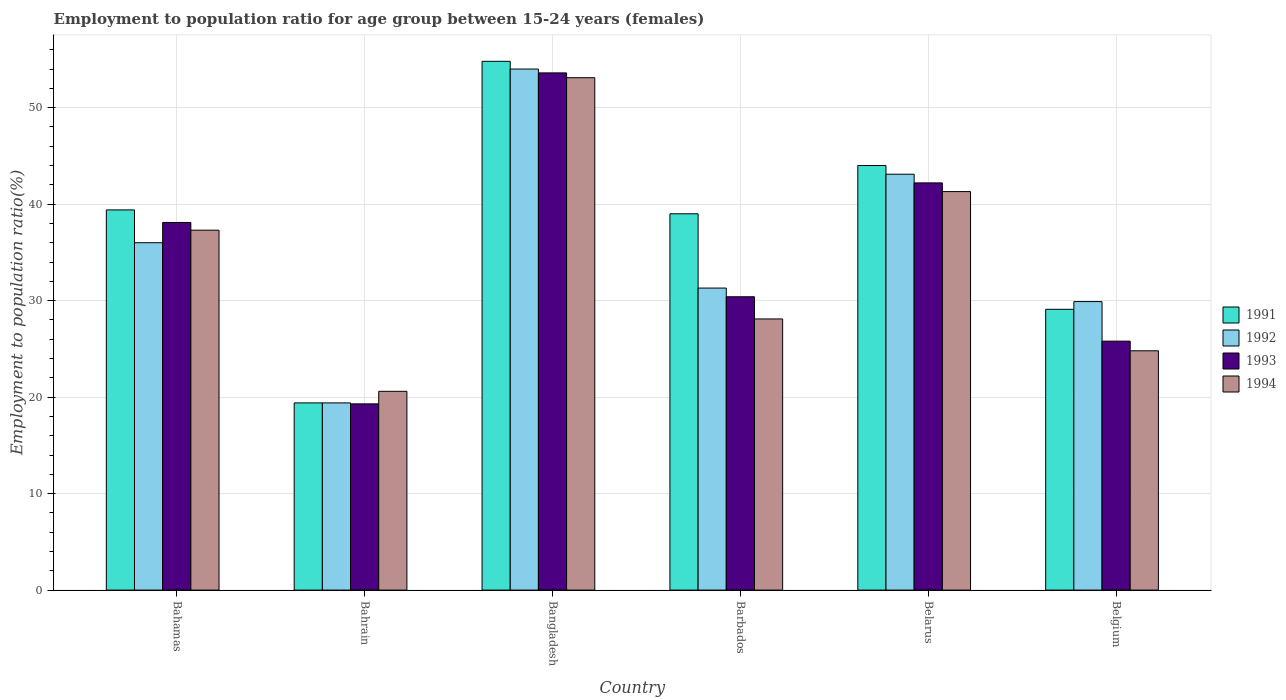Are the number of bars per tick equal to the number of legend labels?
Make the answer very short. Yes. How many bars are there on the 6th tick from the left?
Your answer should be compact. 4. How many bars are there on the 6th tick from the right?
Make the answer very short. 4. What is the label of the 2nd group of bars from the left?
Provide a succinct answer. Bahrain. In how many cases, is the number of bars for a given country not equal to the number of legend labels?
Offer a terse response. 0. What is the employment to population ratio in 1993 in Bangladesh?
Ensure brevity in your answer.  53.6. Across all countries, what is the maximum employment to population ratio in 1993?
Ensure brevity in your answer.  53.6. Across all countries, what is the minimum employment to population ratio in 1991?
Ensure brevity in your answer.  19.4. In which country was the employment to population ratio in 1992 minimum?
Make the answer very short. Bahrain. What is the total employment to population ratio in 1994 in the graph?
Your response must be concise. 205.2. What is the difference between the employment to population ratio in 1991 in Bahamas and that in Bangladesh?
Your answer should be very brief. -15.4. What is the difference between the employment to population ratio in 1994 in Belgium and the employment to population ratio in 1991 in Barbados?
Your answer should be compact. -14.2. What is the average employment to population ratio in 1991 per country?
Provide a short and direct response. 37.62. What is the difference between the employment to population ratio of/in 1991 and employment to population ratio of/in 1992 in Bahrain?
Your answer should be very brief. 0. In how many countries, is the employment to population ratio in 1991 greater than 8 %?
Provide a succinct answer. 6. What is the ratio of the employment to population ratio in 1991 in Bahamas to that in Bangladesh?
Offer a terse response. 0.72. Is the difference between the employment to population ratio in 1991 in Bahrain and Barbados greater than the difference between the employment to population ratio in 1992 in Bahrain and Barbados?
Your answer should be compact. No. What is the difference between the highest and the second highest employment to population ratio in 1991?
Offer a terse response. -10.8. What is the difference between the highest and the lowest employment to population ratio in 1994?
Make the answer very short. 32.5. In how many countries, is the employment to population ratio in 1992 greater than the average employment to population ratio in 1992 taken over all countries?
Offer a very short reply. 3. Is the sum of the employment to population ratio in 1993 in Barbados and Belgium greater than the maximum employment to population ratio in 1994 across all countries?
Ensure brevity in your answer.  Yes. Is it the case that in every country, the sum of the employment to population ratio in 1993 and employment to population ratio in 1992 is greater than the sum of employment to population ratio in 1991 and employment to population ratio in 1994?
Your response must be concise. No. What does the 1st bar from the left in Belgium represents?
Keep it short and to the point. 1991. What does the 3rd bar from the right in Bahamas represents?
Offer a very short reply. 1992. How many bars are there?
Ensure brevity in your answer.  24. Does the graph contain any zero values?
Your answer should be compact. No. How many legend labels are there?
Your response must be concise. 4. How are the legend labels stacked?
Offer a terse response. Vertical. What is the title of the graph?
Ensure brevity in your answer.  Employment to population ratio for age group between 15-24 years (females). What is the Employment to population ratio(%) of 1991 in Bahamas?
Offer a very short reply. 39.4. What is the Employment to population ratio(%) in 1992 in Bahamas?
Ensure brevity in your answer.  36. What is the Employment to population ratio(%) in 1993 in Bahamas?
Provide a short and direct response. 38.1. What is the Employment to population ratio(%) of 1994 in Bahamas?
Keep it short and to the point. 37.3. What is the Employment to population ratio(%) in 1991 in Bahrain?
Ensure brevity in your answer.  19.4. What is the Employment to population ratio(%) of 1992 in Bahrain?
Provide a succinct answer. 19.4. What is the Employment to population ratio(%) in 1993 in Bahrain?
Your answer should be very brief. 19.3. What is the Employment to population ratio(%) of 1994 in Bahrain?
Your response must be concise. 20.6. What is the Employment to population ratio(%) of 1991 in Bangladesh?
Provide a succinct answer. 54.8. What is the Employment to population ratio(%) in 1993 in Bangladesh?
Your answer should be compact. 53.6. What is the Employment to population ratio(%) of 1994 in Bangladesh?
Your answer should be compact. 53.1. What is the Employment to population ratio(%) of 1992 in Barbados?
Offer a very short reply. 31.3. What is the Employment to population ratio(%) of 1993 in Barbados?
Give a very brief answer. 30.4. What is the Employment to population ratio(%) of 1994 in Barbados?
Provide a succinct answer. 28.1. What is the Employment to population ratio(%) of 1991 in Belarus?
Your response must be concise. 44. What is the Employment to population ratio(%) of 1992 in Belarus?
Your answer should be compact. 43.1. What is the Employment to population ratio(%) in 1993 in Belarus?
Make the answer very short. 42.2. What is the Employment to population ratio(%) of 1994 in Belarus?
Provide a succinct answer. 41.3. What is the Employment to population ratio(%) in 1991 in Belgium?
Provide a short and direct response. 29.1. What is the Employment to population ratio(%) in 1992 in Belgium?
Make the answer very short. 29.9. What is the Employment to population ratio(%) in 1993 in Belgium?
Offer a terse response. 25.8. What is the Employment to population ratio(%) of 1994 in Belgium?
Provide a short and direct response. 24.8. Across all countries, what is the maximum Employment to population ratio(%) in 1991?
Offer a terse response. 54.8. Across all countries, what is the maximum Employment to population ratio(%) of 1993?
Ensure brevity in your answer.  53.6. Across all countries, what is the maximum Employment to population ratio(%) of 1994?
Give a very brief answer. 53.1. Across all countries, what is the minimum Employment to population ratio(%) in 1991?
Provide a succinct answer. 19.4. Across all countries, what is the minimum Employment to population ratio(%) in 1992?
Ensure brevity in your answer.  19.4. Across all countries, what is the minimum Employment to population ratio(%) of 1993?
Your answer should be compact. 19.3. Across all countries, what is the minimum Employment to population ratio(%) of 1994?
Your response must be concise. 20.6. What is the total Employment to population ratio(%) in 1991 in the graph?
Provide a short and direct response. 225.7. What is the total Employment to population ratio(%) in 1992 in the graph?
Make the answer very short. 213.7. What is the total Employment to population ratio(%) in 1993 in the graph?
Provide a short and direct response. 209.4. What is the total Employment to population ratio(%) of 1994 in the graph?
Your answer should be very brief. 205.2. What is the difference between the Employment to population ratio(%) of 1991 in Bahamas and that in Bahrain?
Make the answer very short. 20. What is the difference between the Employment to population ratio(%) in 1992 in Bahamas and that in Bahrain?
Provide a short and direct response. 16.6. What is the difference between the Employment to population ratio(%) in 1994 in Bahamas and that in Bahrain?
Offer a very short reply. 16.7. What is the difference between the Employment to population ratio(%) of 1991 in Bahamas and that in Bangladesh?
Your response must be concise. -15.4. What is the difference between the Employment to population ratio(%) of 1993 in Bahamas and that in Bangladesh?
Ensure brevity in your answer.  -15.5. What is the difference between the Employment to population ratio(%) of 1994 in Bahamas and that in Bangladesh?
Your response must be concise. -15.8. What is the difference between the Employment to population ratio(%) in 1992 in Bahamas and that in Barbados?
Your answer should be compact. 4.7. What is the difference between the Employment to population ratio(%) in 1993 in Bahamas and that in Barbados?
Your answer should be compact. 7.7. What is the difference between the Employment to population ratio(%) in 1994 in Bahamas and that in Barbados?
Make the answer very short. 9.2. What is the difference between the Employment to population ratio(%) of 1991 in Bahamas and that in Belarus?
Your response must be concise. -4.6. What is the difference between the Employment to population ratio(%) of 1992 in Bahamas and that in Belarus?
Offer a terse response. -7.1. What is the difference between the Employment to population ratio(%) of 1993 in Bahamas and that in Belarus?
Give a very brief answer. -4.1. What is the difference between the Employment to population ratio(%) of 1994 in Bahamas and that in Belarus?
Keep it short and to the point. -4. What is the difference between the Employment to population ratio(%) of 1991 in Bahamas and that in Belgium?
Keep it short and to the point. 10.3. What is the difference between the Employment to population ratio(%) in 1992 in Bahamas and that in Belgium?
Ensure brevity in your answer.  6.1. What is the difference between the Employment to population ratio(%) in 1993 in Bahamas and that in Belgium?
Give a very brief answer. 12.3. What is the difference between the Employment to population ratio(%) in 1991 in Bahrain and that in Bangladesh?
Keep it short and to the point. -35.4. What is the difference between the Employment to population ratio(%) in 1992 in Bahrain and that in Bangladesh?
Provide a succinct answer. -34.6. What is the difference between the Employment to population ratio(%) of 1993 in Bahrain and that in Bangladesh?
Provide a succinct answer. -34.3. What is the difference between the Employment to population ratio(%) of 1994 in Bahrain and that in Bangladesh?
Ensure brevity in your answer.  -32.5. What is the difference between the Employment to population ratio(%) in 1991 in Bahrain and that in Barbados?
Your answer should be compact. -19.6. What is the difference between the Employment to population ratio(%) of 1992 in Bahrain and that in Barbados?
Provide a short and direct response. -11.9. What is the difference between the Employment to population ratio(%) in 1993 in Bahrain and that in Barbados?
Give a very brief answer. -11.1. What is the difference between the Employment to population ratio(%) in 1994 in Bahrain and that in Barbados?
Your answer should be very brief. -7.5. What is the difference between the Employment to population ratio(%) of 1991 in Bahrain and that in Belarus?
Your answer should be compact. -24.6. What is the difference between the Employment to population ratio(%) of 1992 in Bahrain and that in Belarus?
Provide a succinct answer. -23.7. What is the difference between the Employment to population ratio(%) in 1993 in Bahrain and that in Belarus?
Give a very brief answer. -22.9. What is the difference between the Employment to population ratio(%) in 1994 in Bahrain and that in Belarus?
Offer a very short reply. -20.7. What is the difference between the Employment to population ratio(%) of 1991 in Bahrain and that in Belgium?
Make the answer very short. -9.7. What is the difference between the Employment to population ratio(%) of 1992 in Bahrain and that in Belgium?
Make the answer very short. -10.5. What is the difference between the Employment to population ratio(%) of 1994 in Bahrain and that in Belgium?
Your answer should be very brief. -4.2. What is the difference between the Employment to population ratio(%) of 1992 in Bangladesh and that in Barbados?
Offer a terse response. 22.7. What is the difference between the Employment to population ratio(%) in 1993 in Bangladesh and that in Barbados?
Make the answer very short. 23.2. What is the difference between the Employment to population ratio(%) in 1991 in Bangladesh and that in Belarus?
Offer a very short reply. 10.8. What is the difference between the Employment to population ratio(%) in 1991 in Bangladesh and that in Belgium?
Keep it short and to the point. 25.7. What is the difference between the Employment to population ratio(%) in 1992 in Bangladesh and that in Belgium?
Keep it short and to the point. 24.1. What is the difference between the Employment to population ratio(%) in 1993 in Bangladesh and that in Belgium?
Give a very brief answer. 27.8. What is the difference between the Employment to population ratio(%) of 1994 in Bangladesh and that in Belgium?
Offer a terse response. 28.3. What is the difference between the Employment to population ratio(%) of 1991 in Barbados and that in Belarus?
Your answer should be compact. -5. What is the difference between the Employment to population ratio(%) in 1993 in Barbados and that in Belgium?
Your answer should be compact. 4.6. What is the difference between the Employment to population ratio(%) of 1991 in Belarus and that in Belgium?
Give a very brief answer. 14.9. What is the difference between the Employment to population ratio(%) in 1992 in Belarus and that in Belgium?
Provide a succinct answer. 13.2. What is the difference between the Employment to population ratio(%) in 1993 in Belarus and that in Belgium?
Give a very brief answer. 16.4. What is the difference between the Employment to population ratio(%) in 1991 in Bahamas and the Employment to population ratio(%) in 1993 in Bahrain?
Provide a succinct answer. 20.1. What is the difference between the Employment to population ratio(%) of 1993 in Bahamas and the Employment to population ratio(%) of 1994 in Bahrain?
Offer a very short reply. 17.5. What is the difference between the Employment to population ratio(%) of 1991 in Bahamas and the Employment to population ratio(%) of 1992 in Bangladesh?
Offer a terse response. -14.6. What is the difference between the Employment to population ratio(%) in 1991 in Bahamas and the Employment to population ratio(%) in 1994 in Bangladesh?
Provide a short and direct response. -13.7. What is the difference between the Employment to population ratio(%) in 1992 in Bahamas and the Employment to population ratio(%) in 1993 in Bangladesh?
Ensure brevity in your answer.  -17.6. What is the difference between the Employment to population ratio(%) in 1992 in Bahamas and the Employment to population ratio(%) in 1994 in Bangladesh?
Offer a very short reply. -17.1. What is the difference between the Employment to population ratio(%) in 1991 in Bahamas and the Employment to population ratio(%) in 1992 in Barbados?
Offer a terse response. 8.1. What is the difference between the Employment to population ratio(%) of 1991 in Bahamas and the Employment to population ratio(%) of 1994 in Barbados?
Your answer should be very brief. 11.3. What is the difference between the Employment to population ratio(%) of 1992 in Bahamas and the Employment to population ratio(%) of 1994 in Barbados?
Keep it short and to the point. 7.9. What is the difference between the Employment to population ratio(%) of 1993 in Bahamas and the Employment to population ratio(%) of 1994 in Barbados?
Provide a succinct answer. 10. What is the difference between the Employment to population ratio(%) in 1991 in Bahamas and the Employment to population ratio(%) in 1992 in Belarus?
Provide a succinct answer. -3.7. What is the difference between the Employment to population ratio(%) in 1991 in Bahamas and the Employment to population ratio(%) in 1993 in Belarus?
Give a very brief answer. -2.8. What is the difference between the Employment to population ratio(%) in 1991 in Bahamas and the Employment to population ratio(%) in 1992 in Belgium?
Offer a terse response. 9.5. What is the difference between the Employment to population ratio(%) of 1991 in Bahamas and the Employment to population ratio(%) of 1993 in Belgium?
Your response must be concise. 13.6. What is the difference between the Employment to population ratio(%) in 1992 in Bahamas and the Employment to population ratio(%) in 1994 in Belgium?
Provide a succinct answer. 11.2. What is the difference between the Employment to population ratio(%) in 1993 in Bahamas and the Employment to population ratio(%) in 1994 in Belgium?
Your answer should be very brief. 13.3. What is the difference between the Employment to population ratio(%) of 1991 in Bahrain and the Employment to population ratio(%) of 1992 in Bangladesh?
Offer a terse response. -34.6. What is the difference between the Employment to population ratio(%) of 1991 in Bahrain and the Employment to population ratio(%) of 1993 in Bangladesh?
Keep it short and to the point. -34.2. What is the difference between the Employment to population ratio(%) in 1991 in Bahrain and the Employment to population ratio(%) in 1994 in Bangladesh?
Your answer should be compact. -33.7. What is the difference between the Employment to population ratio(%) of 1992 in Bahrain and the Employment to population ratio(%) of 1993 in Bangladesh?
Make the answer very short. -34.2. What is the difference between the Employment to population ratio(%) in 1992 in Bahrain and the Employment to population ratio(%) in 1994 in Bangladesh?
Keep it short and to the point. -33.7. What is the difference between the Employment to population ratio(%) of 1993 in Bahrain and the Employment to population ratio(%) of 1994 in Bangladesh?
Your answer should be very brief. -33.8. What is the difference between the Employment to population ratio(%) in 1991 in Bahrain and the Employment to population ratio(%) in 1992 in Barbados?
Your answer should be compact. -11.9. What is the difference between the Employment to population ratio(%) in 1992 in Bahrain and the Employment to population ratio(%) in 1994 in Barbados?
Your answer should be very brief. -8.7. What is the difference between the Employment to population ratio(%) of 1993 in Bahrain and the Employment to population ratio(%) of 1994 in Barbados?
Provide a succinct answer. -8.8. What is the difference between the Employment to population ratio(%) in 1991 in Bahrain and the Employment to population ratio(%) in 1992 in Belarus?
Ensure brevity in your answer.  -23.7. What is the difference between the Employment to population ratio(%) of 1991 in Bahrain and the Employment to population ratio(%) of 1993 in Belarus?
Offer a terse response. -22.8. What is the difference between the Employment to population ratio(%) of 1991 in Bahrain and the Employment to population ratio(%) of 1994 in Belarus?
Your response must be concise. -21.9. What is the difference between the Employment to population ratio(%) in 1992 in Bahrain and the Employment to population ratio(%) in 1993 in Belarus?
Your answer should be very brief. -22.8. What is the difference between the Employment to population ratio(%) of 1992 in Bahrain and the Employment to population ratio(%) of 1994 in Belarus?
Make the answer very short. -21.9. What is the difference between the Employment to population ratio(%) of 1993 in Bahrain and the Employment to population ratio(%) of 1994 in Belarus?
Provide a short and direct response. -22. What is the difference between the Employment to population ratio(%) of 1991 in Bahrain and the Employment to population ratio(%) of 1994 in Belgium?
Provide a succinct answer. -5.4. What is the difference between the Employment to population ratio(%) in 1992 in Bahrain and the Employment to population ratio(%) in 1993 in Belgium?
Your response must be concise. -6.4. What is the difference between the Employment to population ratio(%) in 1992 in Bahrain and the Employment to population ratio(%) in 1994 in Belgium?
Offer a very short reply. -5.4. What is the difference between the Employment to population ratio(%) in 1993 in Bahrain and the Employment to population ratio(%) in 1994 in Belgium?
Provide a succinct answer. -5.5. What is the difference between the Employment to population ratio(%) in 1991 in Bangladesh and the Employment to population ratio(%) in 1992 in Barbados?
Your response must be concise. 23.5. What is the difference between the Employment to population ratio(%) in 1991 in Bangladesh and the Employment to population ratio(%) in 1993 in Barbados?
Make the answer very short. 24.4. What is the difference between the Employment to population ratio(%) in 1991 in Bangladesh and the Employment to population ratio(%) in 1994 in Barbados?
Give a very brief answer. 26.7. What is the difference between the Employment to population ratio(%) of 1992 in Bangladesh and the Employment to population ratio(%) of 1993 in Barbados?
Your response must be concise. 23.6. What is the difference between the Employment to population ratio(%) in 1992 in Bangladesh and the Employment to population ratio(%) in 1994 in Barbados?
Make the answer very short. 25.9. What is the difference between the Employment to population ratio(%) in 1993 in Bangladesh and the Employment to population ratio(%) in 1994 in Barbados?
Keep it short and to the point. 25.5. What is the difference between the Employment to population ratio(%) in 1991 in Bangladesh and the Employment to population ratio(%) in 1992 in Belarus?
Your answer should be very brief. 11.7. What is the difference between the Employment to population ratio(%) of 1991 in Bangladesh and the Employment to population ratio(%) of 1994 in Belarus?
Ensure brevity in your answer.  13.5. What is the difference between the Employment to population ratio(%) of 1992 in Bangladesh and the Employment to population ratio(%) of 1993 in Belarus?
Your answer should be compact. 11.8. What is the difference between the Employment to population ratio(%) in 1992 in Bangladesh and the Employment to population ratio(%) in 1994 in Belarus?
Make the answer very short. 12.7. What is the difference between the Employment to population ratio(%) in 1991 in Bangladesh and the Employment to population ratio(%) in 1992 in Belgium?
Your answer should be very brief. 24.9. What is the difference between the Employment to population ratio(%) of 1992 in Bangladesh and the Employment to population ratio(%) of 1993 in Belgium?
Provide a succinct answer. 28.2. What is the difference between the Employment to population ratio(%) in 1992 in Bangladesh and the Employment to population ratio(%) in 1994 in Belgium?
Offer a very short reply. 29.2. What is the difference between the Employment to population ratio(%) in 1993 in Bangladesh and the Employment to population ratio(%) in 1994 in Belgium?
Provide a succinct answer. 28.8. What is the difference between the Employment to population ratio(%) of 1992 in Barbados and the Employment to population ratio(%) of 1994 in Belarus?
Make the answer very short. -10. What is the difference between the Employment to population ratio(%) in 1993 in Barbados and the Employment to population ratio(%) in 1994 in Belarus?
Offer a terse response. -10.9. What is the difference between the Employment to population ratio(%) in 1991 in Barbados and the Employment to population ratio(%) in 1992 in Belgium?
Make the answer very short. 9.1. What is the difference between the Employment to population ratio(%) of 1992 in Barbados and the Employment to population ratio(%) of 1994 in Belgium?
Offer a very short reply. 6.5. What is the difference between the Employment to population ratio(%) of 1991 in Belarus and the Employment to population ratio(%) of 1992 in Belgium?
Your response must be concise. 14.1. What is the difference between the Employment to population ratio(%) in 1993 in Belarus and the Employment to population ratio(%) in 1994 in Belgium?
Offer a terse response. 17.4. What is the average Employment to population ratio(%) in 1991 per country?
Provide a short and direct response. 37.62. What is the average Employment to population ratio(%) in 1992 per country?
Make the answer very short. 35.62. What is the average Employment to population ratio(%) of 1993 per country?
Provide a short and direct response. 34.9. What is the average Employment to population ratio(%) in 1994 per country?
Keep it short and to the point. 34.2. What is the difference between the Employment to population ratio(%) in 1991 and Employment to population ratio(%) in 1992 in Bahamas?
Your response must be concise. 3.4. What is the difference between the Employment to population ratio(%) of 1991 and Employment to population ratio(%) of 1993 in Bahamas?
Provide a short and direct response. 1.3. What is the difference between the Employment to population ratio(%) in 1992 and Employment to population ratio(%) in 1993 in Bahamas?
Keep it short and to the point. -2.1. What is the difference between the Employment to population ratio(%) in 1992 and Employment to population ratio(%) in 1994 in Bahamas?
Offer a terse response. -1.3. What is the difference between the Employment to population ratio(%) in 1991 and Employment to population ratio(%) in 1993 in Bahrain?
Make the answer very short. 0.1. What is the difference between the Employment to population ratio(%) of 1991 and Employment to population ratio(%) of 1994 in Bahrain?
Give a very brief answer. -1.2. What is the difference between the Employment to population ratio(%) of 1993 and Employment to population ratio(%) of 1994 in Bahrain?
Your answer should be very brief. -1.3. What is the difference between the Employment to population ratio(%) in 1991 and Employment to population ratio(%) in 1992 in Bangladesh?
Offer a very short reply. 0.8. What is the difference between the Employment to population ratio(%) of 1992 and Employment to population ratio(%) of 1994 in Bangladesh?
Ensure brevity in your answer.  0.9. What is the difference between the Employment to population ratio(%) of 1991 and Employment to population ratio(%) of 1992 in Barbados?
Your answer should be very brief. 7.7. What is the difference between the Employment to population ratio(%) in 1992 and Employment to population ratio(%) in 1994 in Barbados?
Your answer should be compact. 3.2. What is the difference between the Employment to population ratio(%) in 1993 and Employment to population ratio(%) in 1994 in Barbados?
Offer a terse response. 2.3. What is the difference between the Employment to population ratio(%) in 1991 and Employment to population ratio(%) in 1992 in Belarus?
Keep it short and to the point. 0.9. What is the difference between the Employment to population ratio(%) in 1991 and Employment to population ratio(%) in 1993 in Belarus?
Give a very brief answer. 1.8. What is the difference between the Employment to population ratio(%) in 1992 and Employment to population ratio(%) in 1994 in Belarus?
Provide a short and direct response. 1.8. What is the difference between the Employment to population ratio(%) in 1991 and Employment to population ratio(%) in 1992 in Belgium?
Give a very brief answer. -0.8. What is the difference between the Employment to population ratio(%) in 1992 and Employment to population ratio(%) in 1993 in Belgium?
Offer a very short reply. 4.1. What is the difference between the Employment to population ratio(%) of 1993 and Employment to population ratio(%) of 1994 in Belgium?
Your answer should be compact. 1. What is the ratio of the Employment to population ratio(%) of 1991 in Bahamas to that in Bahrain?
Provide a short and direct response. 2.03. What is the ratio of the Employment to population ratio(%) of 1992 in Bahamas to that in Bahrain?
Your response must be concise. 1.86. What is the ratio of the Employment to population ratio(%) in 1993 in Bahamas to that in Bahrain?
Give a very brief answer. 1.97. What is the ratio of the Employment to population ratio(%) in 1994 in Bahamas to that in Bahrain?
Offer a terse response. 1.81. What is the ratio of the Employment to population ratio(%) of 1991 in Bahamas to that in Bangladesh?
Give a very brief answer. 0.72. What is the ratio of the Employment to population ratio(%) in 1992 in Bahamas to that in Bangladesh?
Give a very brief answer. 0.67. What is the ratio of the Employment to population ratio(%) in 1993 in Bahamas to that in Bangladesh?
Your answer should be very brief. 0.71. What is the ratio of the Employment to population ratio(%) in 1994 in Bahamas to that in Bangladesh?
Give a very brief answer. 0.7. What is the ratio of the Employment to population ratio(%) in 1991 in Bahamas to that in Barbados?
Make the answer very short. 1.01. What is the ratio of the Employment to population ratio(%) in 1992 in Bahamas to that in Barbados?
Your response must be concise. 1.15. What is the ratio of the Employment to population ratio(%) in 1993 in Bahamas to that in Barbados?
Make the answer very short. 1.25. What is the ratio of the Employment to population ratio(%) in 1994 in Bahamas to that in Barbados?
Make the answer very short. 1.33. What is the ratio of the Employment to population ratio(%) in 1991 in Bahamas to that in Belarus?
Ensure brevity in your answer.  0.9. What is the ratio of the Employment to population ratio(%) of 1992 in Bahamas to that in Belarus?
Give a very brief answer. 0.84. What is the ratio of the Employment to population ratio(%) in 1993 in Bahamas to that in Belarus?
Make the answer very short. 0.9. What is the ratio of the Employment to population ratio(%) in 1994 in Bahamas to that in Belarus?
Your answer should be very brief. 0.9. What is the ratio of the Employment to population ratio(%) in 1991 in Bahamas to that in Belgium?
Provide a short and direct response. 1.35. What is the ratio of the Employment to population ratio(%) of 1992 in Bahamas to that in Belgium?
Your answer should be very brief. 1.2. What is the ratio of the Employment to population ratio(%) in 1993 in Bahamas to that in Belgium?
Ensure brevity in your answer.  1.48. What is the ratio of the Employment to population ratio(%) of 1994 in Bahamas to that in Belgium?
Ensure brevity in your answer.  1.5. What is the ratio of the Employment to population ratio(%) of 1991 in Bahrain to that in Bangladesh?
Offer a very short reply. 0.35. What is the ratio of the Employment to population ratio(%) of 1992 in Bahrain to that in Bangladesh?
Your response must be concise. 0.36. What is the ratio of the Employment to population ratio(%) in 1993 in Bahrain to that in Bangladesh?
Keep it short and to the point. 0.36. What is the ratio of the Employment to population ratio(%) of 1994 in Bahrain to that in Bangladesh?
Your response must be concise. 0.39. What is the ratio of the Employment to population ratio(%) in 1991 in Bahrain to that in Barbados?
Offer a very short reply. 0.5. What is the ratio of the Employment to population ratio(%) of 1992 in Bahrain to that in Barbados?
Provide a short and direct response. 0.62. What is the ratio of the Employment to population ratio(%) of 1993 in Bahrain to that in Barbados?
Offer a very short reply. 0.63. What is the ratio of the Employment to population ratio(%) in 1994 in Bahrain to that in Barbados?
Offer a terse response. 0.73. What is the ratio of the Employment to population ratio(%) in 1991 in Bahrain to that in Belarus?
Provide a short and direct response. 0.44. What is the ratio of the Employment to population ratio(%) in 1992 in Bahrain to that in Belarus?
Ensure brevity in your answer.  0.45. What is the ratio of the Employment to population ratio(%) in 1993 in Bahrain to that in Belarus?
Provide a succinct answer. 0.46. What is the ratio of the Employment to population ratio(%) of 1994 in Bahrain to that in Belarus?
Your answer should be compact. 0.5. What is the ratio of the Employment to population ratio(%) in 1991 in Bahrain to that in Belgium?
Make the answer very short. 0.67. What is the ratio of the Employment to population ratio(%) of 1992 in Bahrain to that in Belgium?
Give a very brief answer. 0.65. What is the ratio of the Employment to population ratio(%) of 1993 in Bahrain to that in Belgium?
Your response must be concise. 0.75. What is the ratio of the Employment to population ratio(%) in 1994 in Bahrain to that in Belgium?
Your answer should be compact. 0.83. What is the ratio of the Employment to population ratio(%) in 1991 in Bangladesh to that in Barbados?
Your answer should be compact. 1.41. What is the ratio of the Employment to population ratio(%) in 1992 in Bangladesh to that in Barbados?
Your answer should be very brief. 1.73. What is the ratio of the Employment to population ratio(%) of 1993 in Bangladesh to that in Barbados?
Your answer should be compact. 1.76. What is the ratio of the Employment to population ratio(%) in 1994 in Bangladesh to that in Barbados?
Ensure brevity in your answer.  1.89. What is the ratio of the Employment to population ratio(%) of 1991 in Bangladesh to that in Belarus?
Ensure brevity in your answer.  1.25. What is the ratio of the Employment to population ratio(%) of 1992 in Bangladesh to that in Belarus?
Offer a very short reply. 1.25. What is the ratio of the Employment to population ratio(%) of 1993 in Bangladesh to that in Belarus?
Provide a succinct answer. 1.27. What is the ratio of the Employment to population ratio(%) in 1994 in Bangladesh to that in Belarus?
Offer a terse response. 1.29. What is the ratio of the Employment to population ratio(%) in 1991 in Bangladesh to that in Belgium?
Your answer should be very brief. 1.88. What is the ratio of the Employment to population ratio(%) in 1992 in Bangladesh to that in Belgium?
Offer a very short reply. 1.81. What is the ratio of the Employment to population ratio(%) in 1993 in Bangladesh to that in Belgium?
Give a very brief answer. 2.08. What is the ratio of the Employment to population ratio(%) of 1994 in Bangladesh to that in Belgium?
Provide a succinct answer. 2.14. What is the ratio of the Employment to population ratio(%) of 1991 in Barbados to that in Belarus?
Offer a terse response. 0.89. What is the ratio of the Employment to population ratio(%) of 1992 in Barbados to that in Belarus?
Provide a short and direct response. 0.73. What is the ratio of the Employment to population ratio(%) in 1993 in Barbados to that in Belarus?
Offer a terse response. 0.72. What is the ratio of the Employment to population ratio(%) of 1994 in Barbados to that in Belarus?
Your answer should be compact. 0.68. What is the ratio of the Employment to population ratio(%) in 1991 in Barbados to that in Belgium?
Your answer should be very brief. 1.34. What is the ratio of the Employment to population ratio(%) in 1992 in Barbados to that in Belgium?
Your answer should be very brief. 1.05. What is the ratio of the Employment to population ratio(%) in 1993 in Barbados to that in Belgium?
Provide a succinct answer. 1.18. What is the ratio of the Employment to population ratio(%) of 1994 in Barbados to that in Belgium?
Provide a short and direct response. 1.13. What is the ratio of the Employment to population ratio(%) in 1991 in Belarus to that in Belgium?
Your answer should be compact. 1.51. What is the ratio of the Employment to population ratio(%) of 1992 in Belarus to that in Belgium?
Offer a very short reply. 1.44. What is the ratio of the Employment to population ratio(%) in 1993 in Belarus to that in Belgium?
Provide a short and direct response. 1.64. What is the ratio of the Employment to population ratio(%) of 1994 in Belarus to that in Belgium?
Offer a terse response. 1.67. What is the difference between the highest and the second highest Employment to population ratio(%) of 1991?
Make the answer very short. 10.8. What is the difference between the highest and the second highest Employment to population ratio(%) of 1992?
Give a very brief answer. 10.9. What is the difference between the highest and the lowest Employment to population ratio(%) of 1991?
Make the answer very short. 35.4. What is the difference between the highest and the lowest Employment to population ratio(%) in 1992?
Make the answer very short. 34.6. What is the difference between the highest and the lowest Employment to population ratio(%) of 1993?
Provide a succinct answer. 34.3. What is the difference between the highest and the lowest Employment to population ratio(%) of 1994?
Your answer should be very brief. 32.5. 